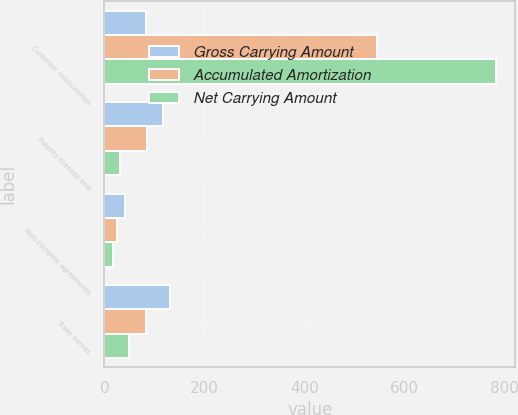Convert chart. <chart><loc_0><loc_0><loc_500><loc_500><stacked_bar_chart><ecel><fcel>Customer relationships<fcel>Patents licenses and<fcel>Non-compete agreements<fcel>Trade names<nl><fcel>Gross Carrying Amount<fcel>83<fcel>116.2<fcel>41.6<fcel>131.4<nl><fcel>Accumulated Amortization<fcel>545.1<fcel>85.4<fcel>25.3<fcel>83<nl><fcel>Net Carrying Amount<fcel>781.9<fcel>30.8<fcel>16.3<fcel>48.4<nl></chart> 